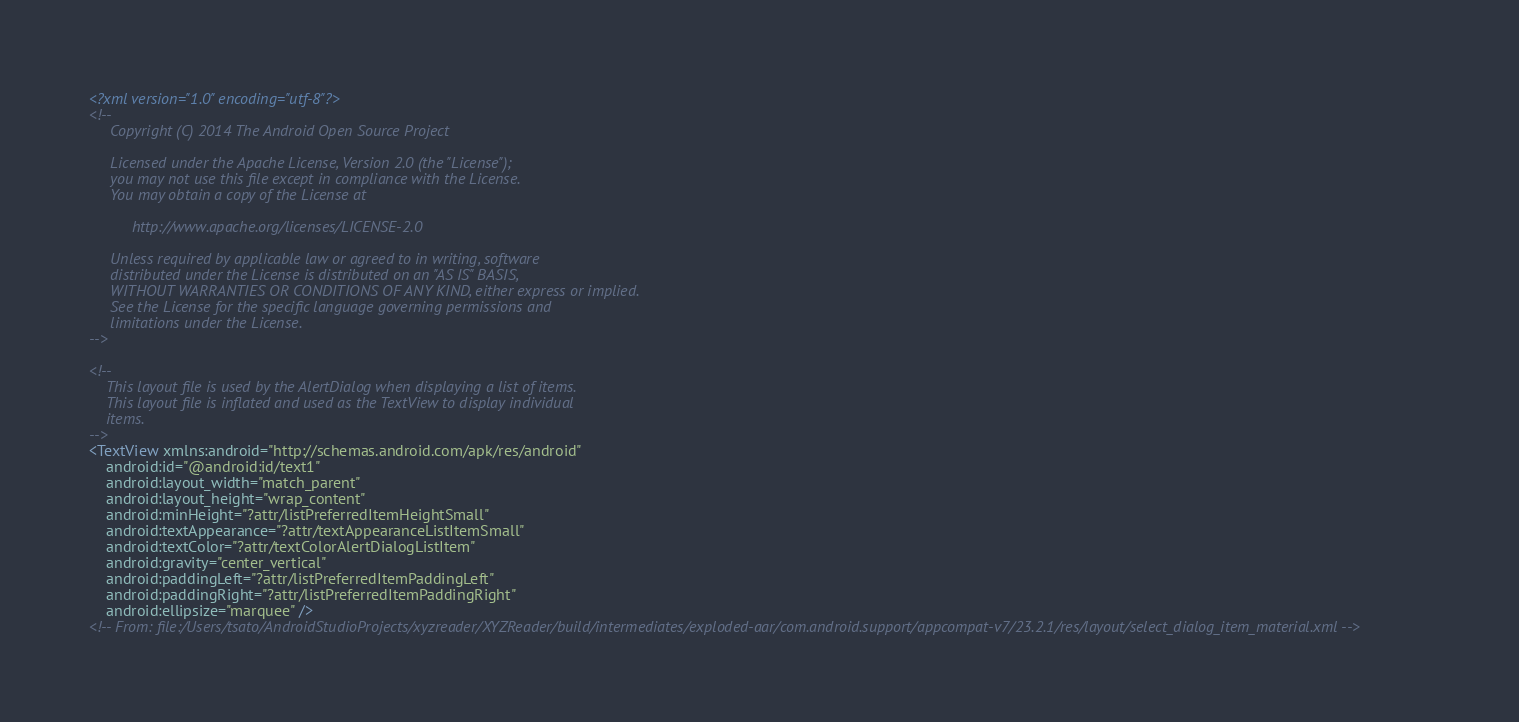<code> <loc_0><loc_0><loc_500><loc_500><_XML_><?xml version="1.0" encoding="utf-8"?>
<!--
     Copyright (C) 2014 The Android Open Source Project

     Licensed under the Apache License, Version 2.0 (the "License");
     you may not use this file except in compliance with the License.
     You may obtain a copy of the License at

          http://www.apache.org/licenses/LICENSE-2.0

     Unless required by applicable law or agreed to in writing, software
     distributed under the License is distributed on an "AS IS" BASIS,
     WITHOUT WARRANTIES OR CONDITIONS OF ANY KIND, either express or implied.
     See the License for the specific language governing permissions and
     limitations under the License.
-->

<!--
    This layout file is used by the AlertDialog when displaying a list of items.
    This layout file is inflated and used as the TextView to display individual
    items.
-->
<TextView xmlns:android="http://schemas.android.com/apk/res/android"
    android:id="@android:id/text1"
    android:layout_width="match_parent"
    android:layout_height="wrap_content"
    android:minHeight="?attr/listPreferredItemHeightSmall"
    android:textAppearance="?attr/textAppearanceListItemSmall"
    android:textColor="?attr/textColorAlertDialogListItem"
    android:gravity="center_vertical"
    android:paddingLeft="?attr/listPreferredItemPaddingLeft"
    android:paddingRight="?attr/listPreferredItemPaddingRight"
    android:ellipsize="marquee" />
<!-- From: file:/Users/tsato/AndroidStudioProjects/xyzreader/XYZReader/build/intermediates/exploded-aar/com.android.support/appcompat-v7/23.2.1/res/layout/select_dialog_item_material.xml --></code> 